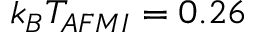<formula> <loc_0><loc_0><loc_500><loc_500>k _ { B } T _ { A F M I } = 0 . 2 6</formula> 